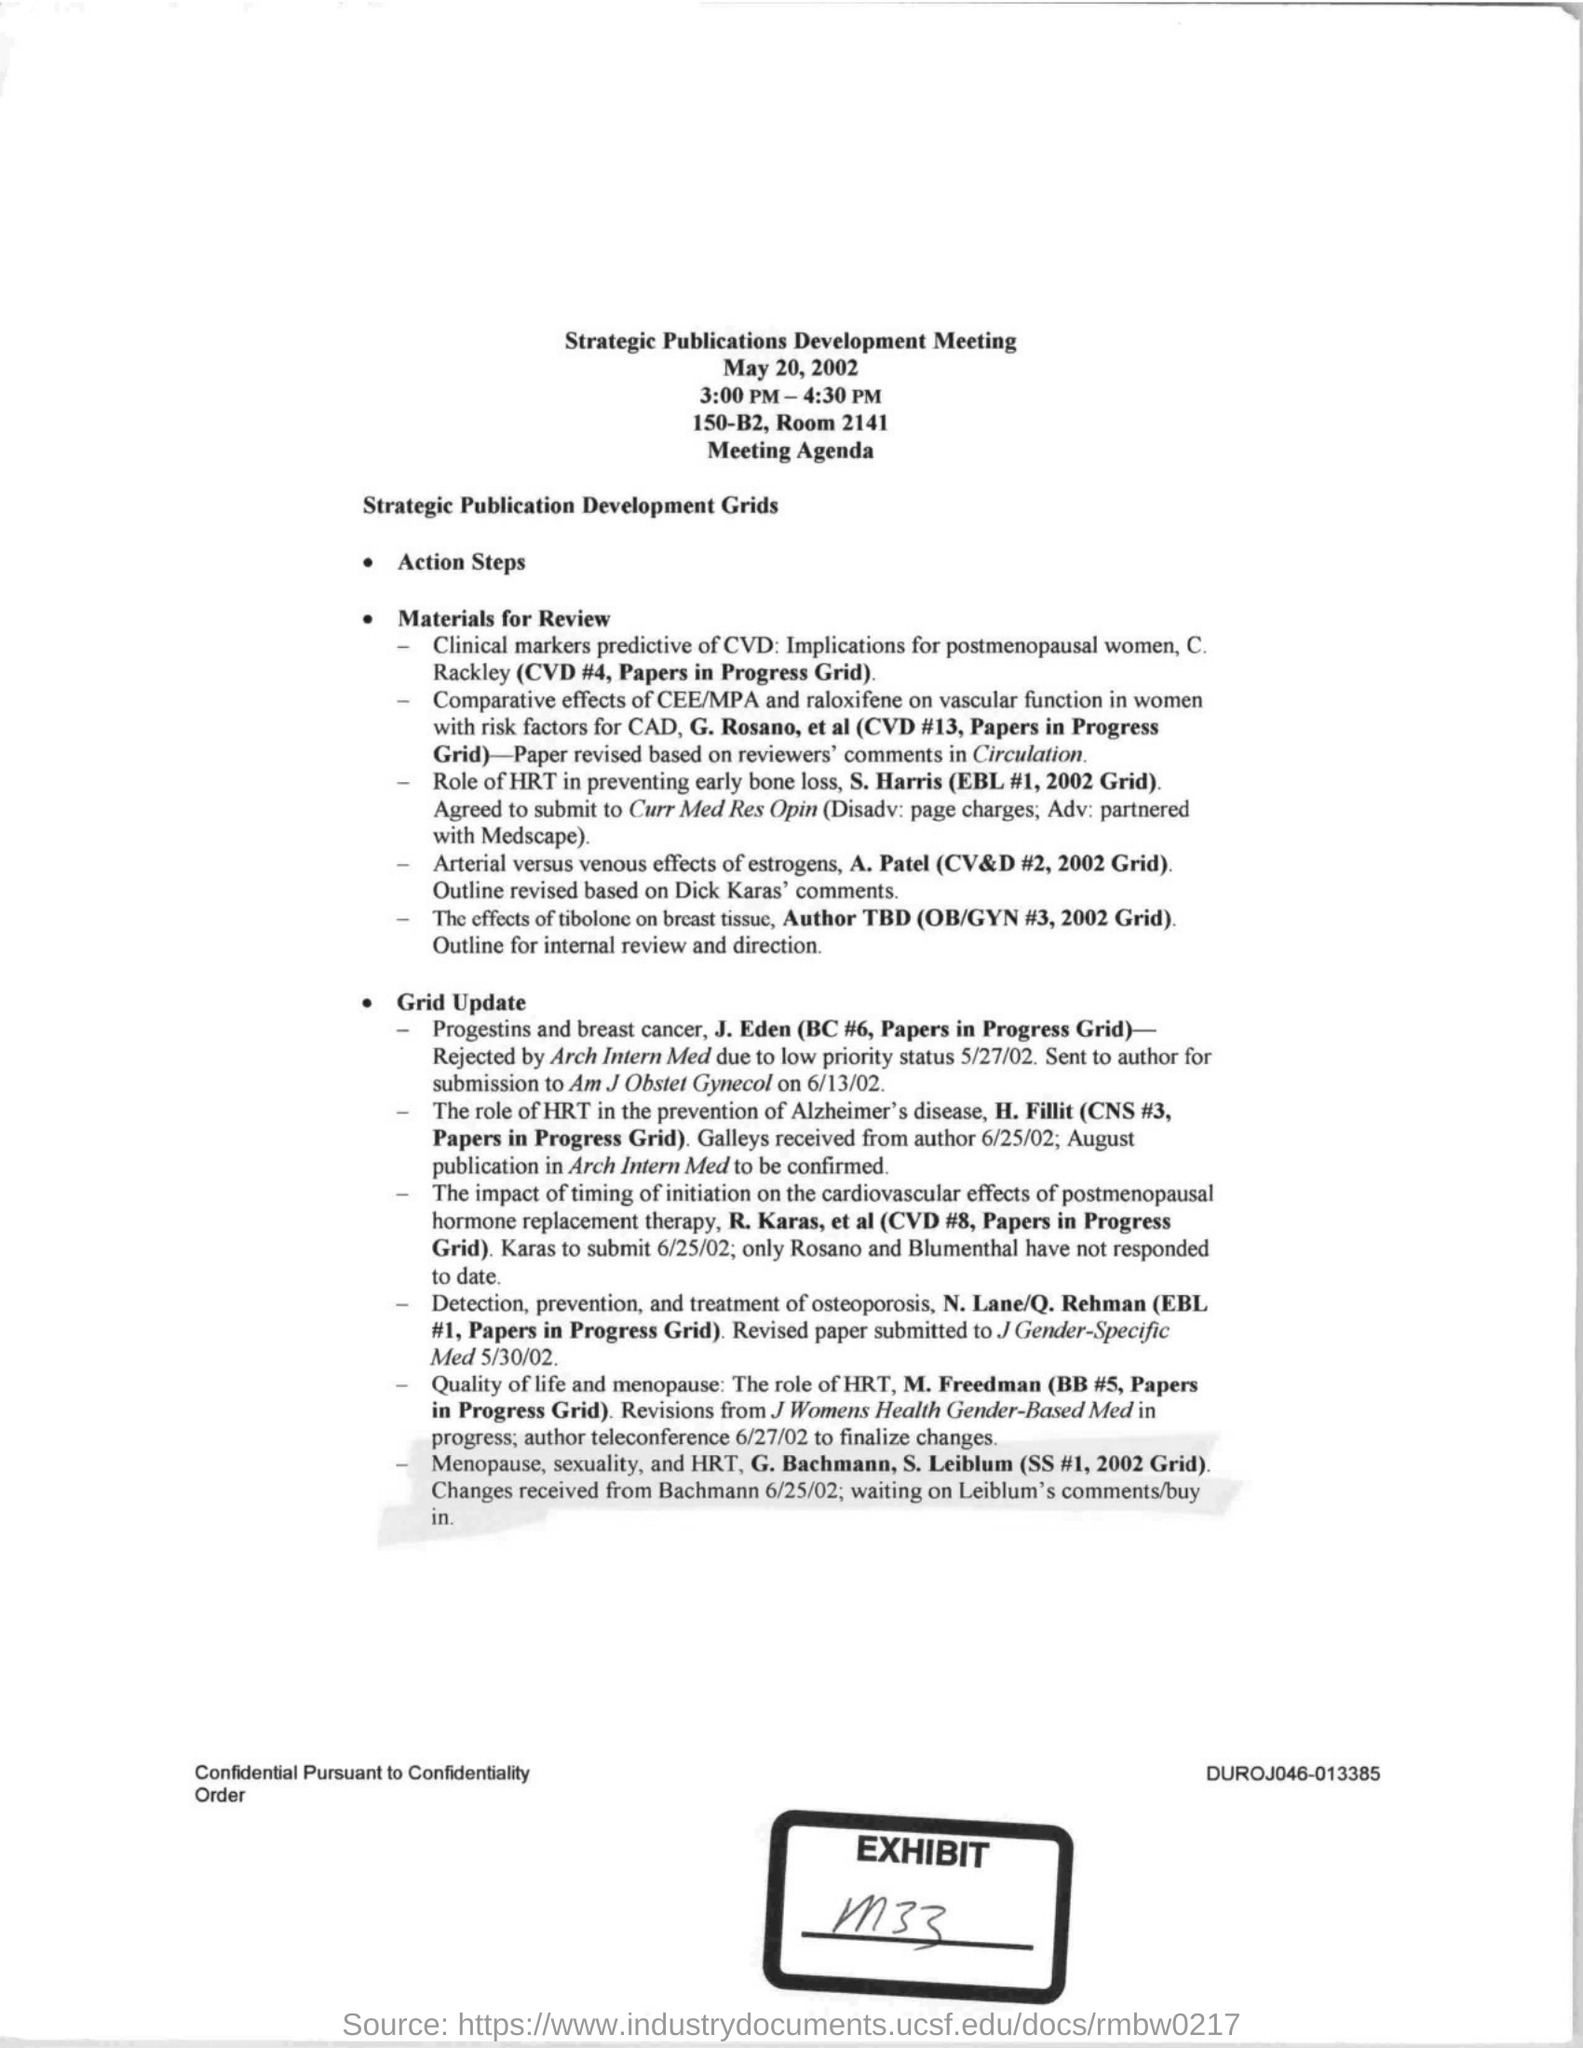What date is the Strategic Publications Development Meeting held?
Provide a short and direct response. May 20, 2002. What time is the Strategic Publications Development Meeting held?
Make the answer very short. 3:00 PM - 4:30 PM. Where is the Strategic Publications Development Meeting organized?
Provide a short and direct response. 150-B2, Room 2141. 